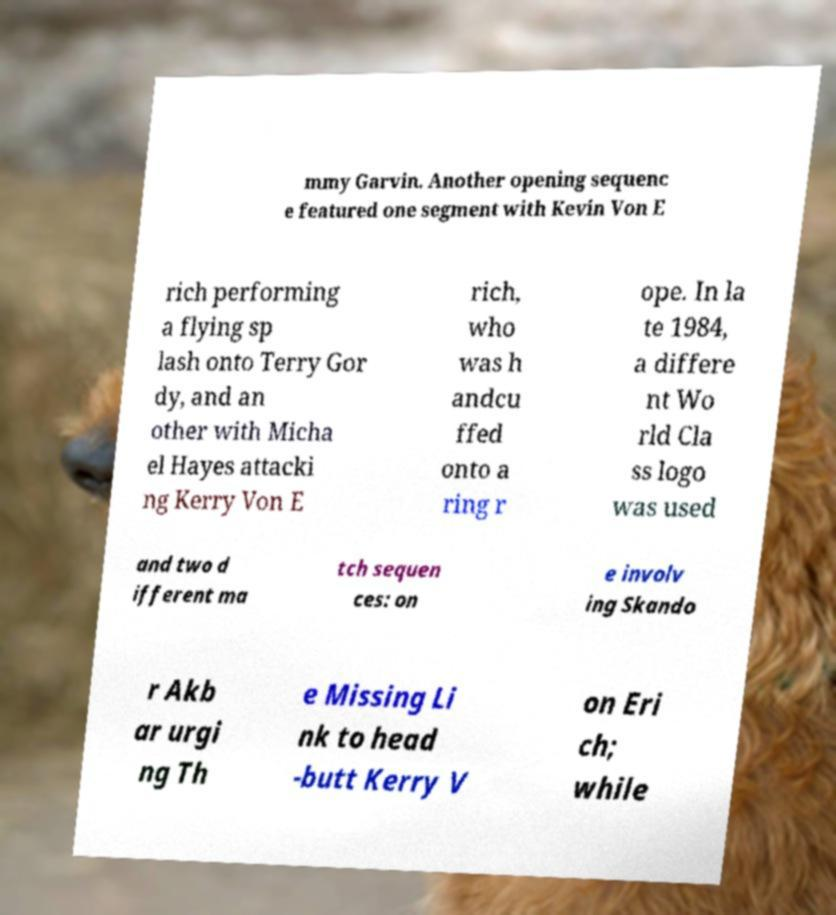Could you assist in decoding the text presented in this image and type it out clearly? mmy Garvin. Another opening sequenc e featured one segment with Kevin Von E rich performing a flying sp lash onto Terry Gor dy, and an other with Micha el Hayes attacki ng Kerry Von E rich, who was h andcu ffed onto a ring r ope. In la te 1984, a differe nt Wo rld Cla ss logo was used and two d ifferent ma tch sequen ces: on e involv ing Skando r Akb ar urgi ng Th e Missing Li nk to head -butt Kerry V on Eri ch; while 